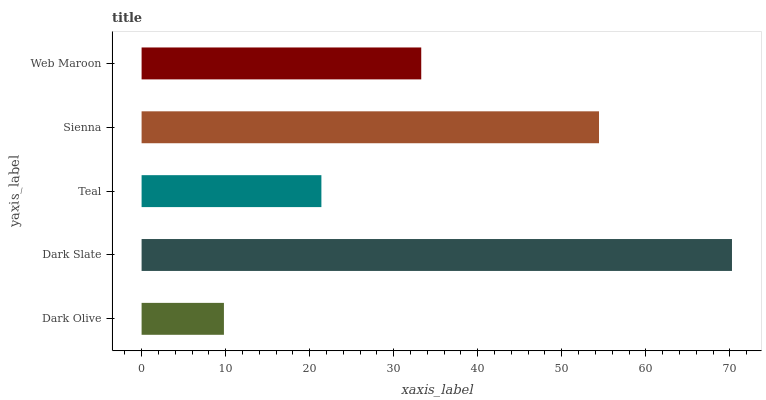Is Dark Olive the minimum?
Answer yes or no. Yes. Is Dark Slate the maximum?
Answer yes or no. Yes. Is Teal the minimum?
Answer yes or no. No. Is Teal the maximum?
Answer yes or no. No. Is Dark Slate greater than Teal?
Answer yes or no. Yes. Is Teal less than Dark Slate?
Answer yes or no. Yes. Is Teal greater than Dark Slate?
Answer yes or no. No. Is Dark Slate less than Teal?
Answer yes or no. No. Is Web Maroon the high median?
Answer yes or no. Yes. Is Web Maroon the low median?
Answer yes or no. Yes. Is Teal the high median?
Answer yes or no. No. Is Dark Slate the low median?
Answer yes or no. No. 